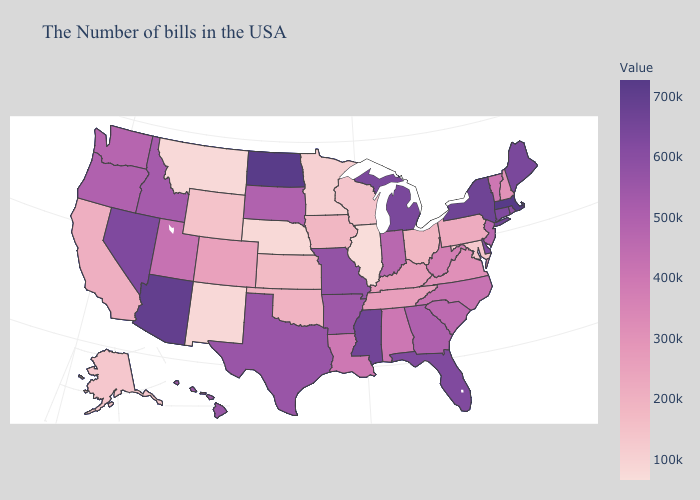Which states have the highest value in the USA?
Keep it brief. Massachusetts. Does Missouri have the highest value in the USA?
Be succinct. No. 